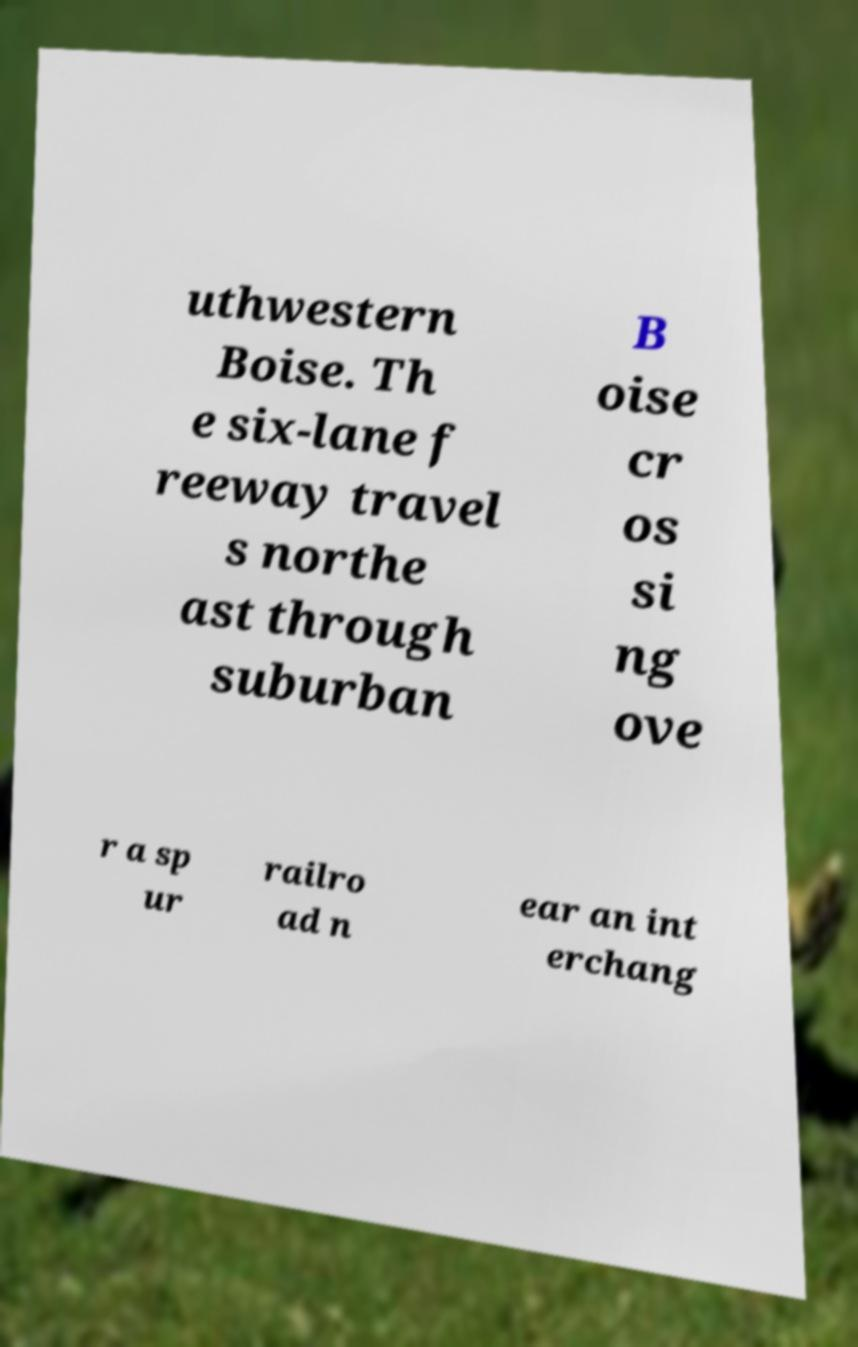Can you read and provide the text displayed in the image?This photo seems to have some interesting text. Can you extract and type it out for me? uthwestern Boise. Th e six-lane f reeway travel s northe ast through suburban B oise cr os si ng ove r a sp ur railro ad n ear an int erchang 